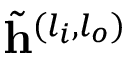Convert formula to latex. <formula><loc_0><loc_0><loc_500><loc_500>\tilde { h } ^ { ( l _ { i } , l _ { o } ) }</formula> 